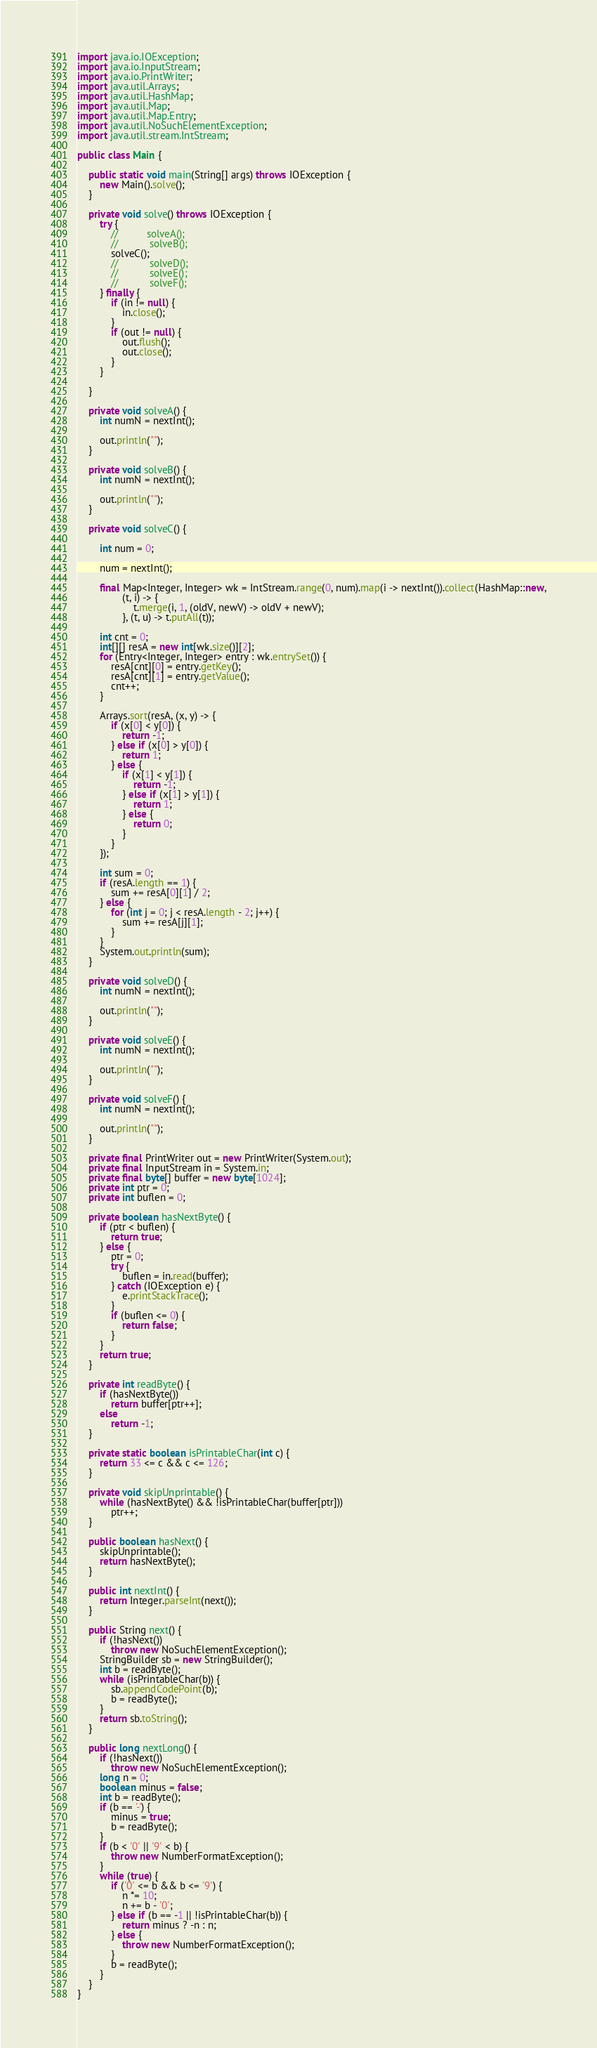<code> <loc_0><loc_0><loc_500><loc_500><_Java_>
import java.io.IOException;
import java.io.InputStream;
import java.io.PrintWriter;
import java.util.Arrays;
import java.util.HashMap;
import java.util.Map;
import java.util.Map.Entry;
import java.util.NoSuchElementException;
import java.util.stream.IntStream;

public class Main {

	public static void main(String[] args) throws IOException {
		new Main().solve();
	}

	private void solve() throws IOException {
		try {
			//			solveA();
			//			 solveB();
			solveC();
			//			 solveD();
			//			 solveE();
			//			 solveF();
		} finally {
			if (in != null) {
				in.close();
			}
			if (out != null) {
				out.flush();
				out.close();
			}
		}

	}

	private void solveA() {
		int numN = nextInt();

		out.println("");
	}

	private void solveB() {
		int numN = nextInt();

		out.println("");
	}

	private void solveC() {

		int num = 0;

		num = nextInt();

		final Map<Integer, Integer> wk = IntStream.range(0, num).map(i -> nextInt()).collect(HashMap::new,
				(t, i) -> {
					t.merge(i, 1, (oldV, newV) -> oldV + newV);
				}, (t, u) -> t.putAll(t));

		int cnt = 0;
		int[][] resA = new int[wk.size()][2];
		for (Entry<Integer, Integer> entry : wk.entrySet()) {
			resA[cnt][0] = entry.getKey();
			resA[cnt][1] = entry.getValue();
			cnt++;
		}

		Arrays.sort(resA, (x, y) -> {
			if (x[0] < y[0]) {
				return -1;
			} else if (x[0] > y[0]) {
				return 1;
			} else {
				if (x[1] < y[1]) {
					return -1;
				} else if (x[1] > y[1]) {
					return 1;
				} else {
					return 0;
				}
			}
		});

		int sum = 0;
		if (resA.length == 1) {
			sum += resA[0][1] / 2;
		} else {
			for (int j = 0; j < resA.length - 2; j++) {
				sum += resA[j][1];
			}
		}
		System.out.println(sum);
	}

	private void solveD() {
		int numN = nextInt();

		out.println("");
	}

	private void solveE() {
		int numN = nextInt();

		out.println("");
	}

	private void solveF() {
		int numN = nextInt();

		out.println("");
	}

	private final PrintWriter out = new PrintWriter(System.out);
	private final InputStream in = System.in;
	private final byte[] buffer = new byte[1024];
	private int ptr = 0;
	private int buflen = 0;

	private boolean hasNextByte() {
		if (ptr < buflen) {
			return true;
		} else {
			ptr = 0;
			try {
				buflen = in.read(buffer);
			} catch (IOException e) {
				e.printStackTrace();
			}
			if (buflen <= 0) {
				return false;
			}
		}
		return true;
	}

	private int readByte() {
		if (hasNextByte())
			return buffer[ptr++];
		else
			return -1;
	}

	private static boolean isPrintableChar(int c) {
		return 33 <= c && c <= 126;
	}

	private void skipUnprintable() {
		while (hasNextByte() && !isPrintableChar(buffer[ptr]))
			ptr++;
	}

	public boolean hasNext() {
		skipUnprintable();
		return hasNextByte();
	}

	public int nextInt() {
		return Integer.parseInt(next());
	}

	public String next() {
		if (!hasNext())
			throw new NoSuchElementException();
		StringBuilder sb = new StringBuilder();
		int b = readByte();
		while (isPrintableChar(b)) {
			sb.appendCodePoint(b);
			b = readByte();
		}
		return sb.toString();
	}

	public long nextLong() {
		if (!hasNext())
			throw new NoSuchElementException();
		long n = 0;
		boolean minus = false;
		int b = readByte();
		if (b == '-') {
			minus = true;
			b = readByte();
		}
		if (b < '0' || '9' < b) {
			throw new NumberFormatException();
		}
		while (true) {
			if ('0' <= b && b <= '9') {
				n *= 10;
				n += b - '0';
			} else if (b == -1 || !isPrintableChar(b)) {
				return minus ? -n : n;
			} else {
				throw new NumberFormatException();
			}
			b = readByte();
		}
	}
}</code> 